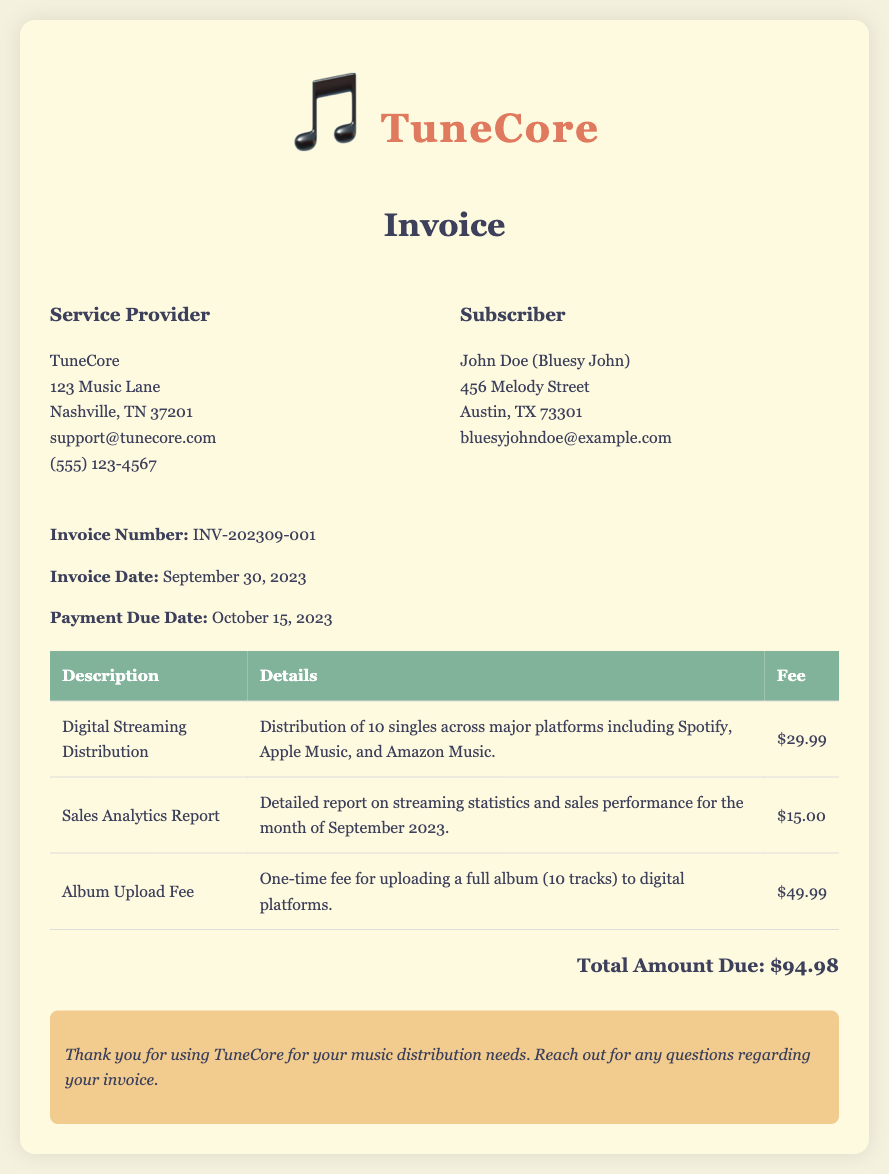what is the invoice number? The invoice number is listed clearly in the document.
Answer: INV-202309-001 what is the service provider's name? The name of the service provider is found in the header of the invoice.
Answer: TuneCore when is the payment due date? The payment due date is mentioned in the invoice details section.
Answer: October 15, 2023 how much is the fee for digital streaming distribution? This fee is listed in the table under the fee column for digital streaming distribution.
Answer: $29.99 what is included in the sales analytics report? The description of the sales analytics report provides details on its contents.
Answer: Detailed report on streaming statistics and sales performance what is the total amount due? The total amount due is calculated and presented at the end of the invoice.
Answer: $94.98 who is the subscriber? The subscriber's name is provided in the invoice details section.
Answer: John Doe (Bluesy John) what services are provided by TuneCore? The table describes the specific services offered, which are digital streaming distribution and sales analytics.
Answer: Distribution and analytics how many singles are distributed across platforms? The number of singles is indicated in the details for digital streaming distribution.
Answer: 10 singles 